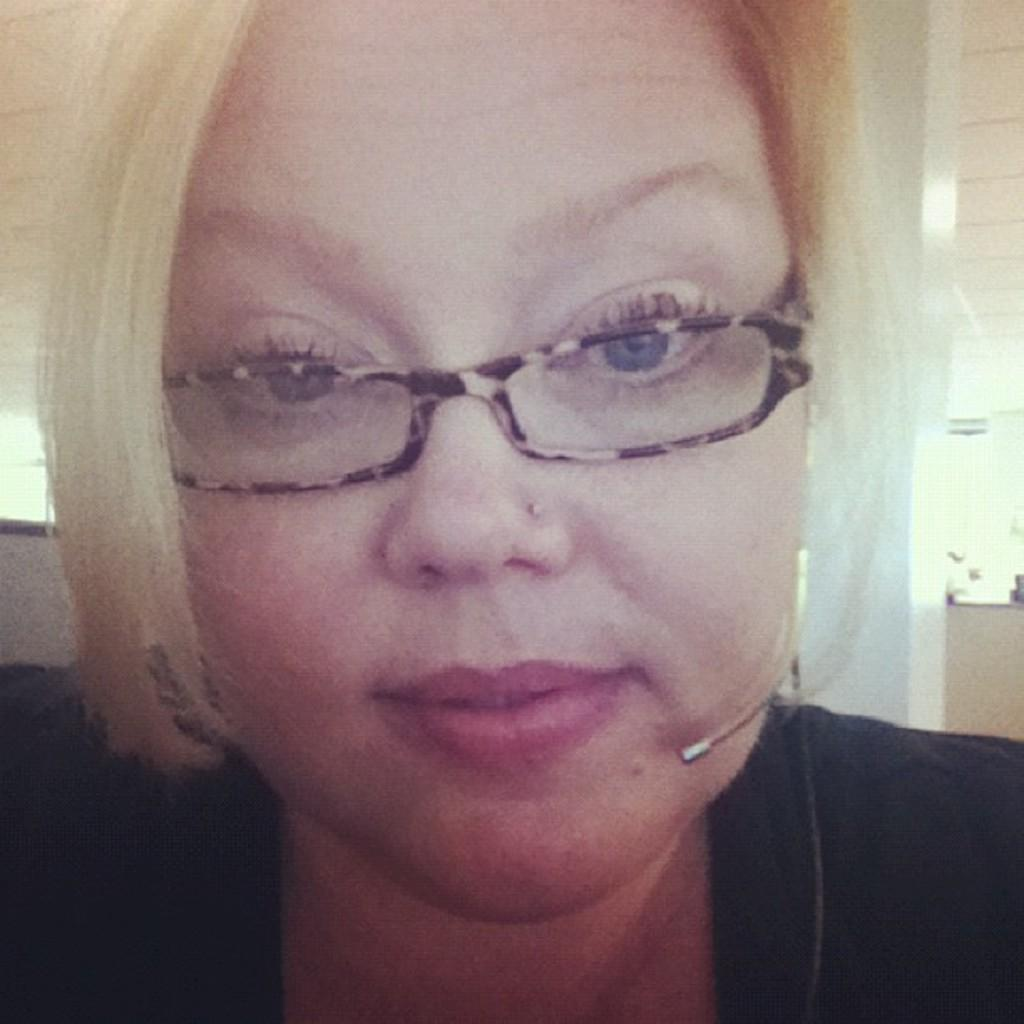Who is present in the image? There is a woman in the image. What is the woman wearing on her face? The woman is wearing spectacles. What type of knot is the woman tying in the image? There is no knot present in the image. What kind of gun is the woman holding in the image? There is no gun present in the image. 